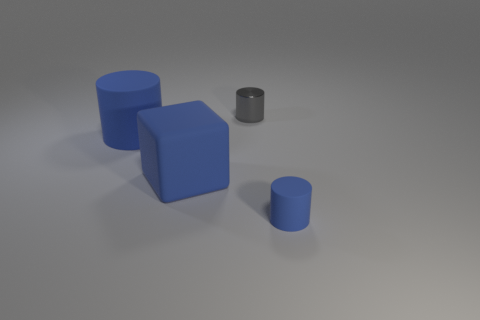Add 1 blue rubber objects. How many objects exist? 5 Subtract all blocks. How many objects are left? 3 Add 2 big blue shiny cylinders. How many big blue shiny cylinders exist? 2 Subtract 0 brown cylinders. How many objects are left? 4 Subtract all metal objects. Subtract all blue rubber cylinders. How many objects are left? 1 Add 3 small gray things. How many small gray things are left? 4 